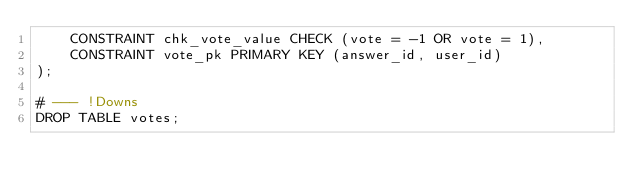<code> <loc_0><loc_0><loc_500><loc_500><_SQL_>    CONSTRAINT chk_vote_value CHECK (vote = -1 OR vote = 1),
    CONSTRAINT vote_pk PRIMARY KEY (answer_id, user_id)
);

# --- !Downs
DROP TABLE votes;
</code> 